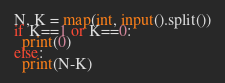Convert code to text. <code><loc_0><loc_0><loc_500><loc_500><_Python_>N, K = map(int, input().split())
if K==1 or K==0:
  print(0)
else:
  print(N-K)</code> 